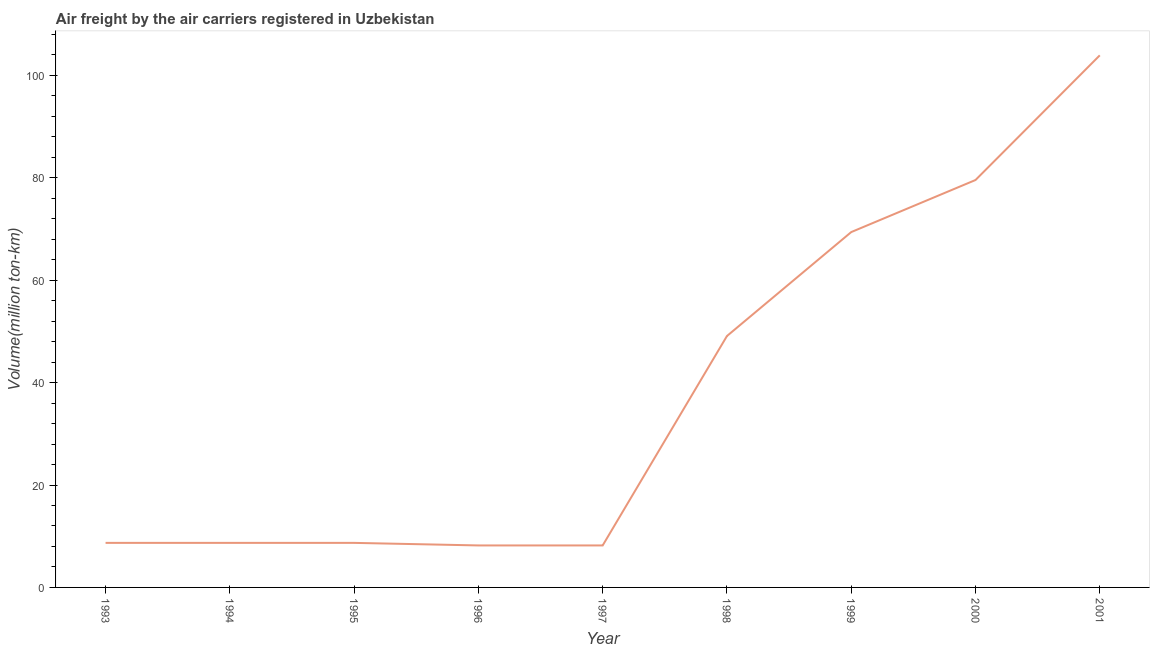What is the air freight in 1994?
Ensure brevity in your answer.  8.7. Across all years, what is the maximum air freight?
Your answer should be very brief. 103.92. Across all years, what is the minimum air freight?
Give a very brief answer. 8.2. In which year was the air freight maximum?
Your answer should be compact. 2001. What is the sum of the air freight?
Ensure brevity in your answer.  344.49. What is the average air freight per year?
Give a very brief answer. 38.28. What is the median air freight?
Give a very brief answer. 8.7. What is the ratio of the air freight in 1995 to that in 2000?
Your response must be concise. 0.11. Is the difference between the air freight in 1995 and 1998 greater than the difference between any two years?
Your answer should be compact. No. What is the difference between the highest and the second highest air freight?
Your answer should be compact. 24.35. Is the sum of the air freight in 1999 and 2000 greater than the maximum air freight across all years?
Give a very brief answer. Yes. What is the difference between the highest and the lowest air freight?
Provide a succinct answer. 95.72. In how many years, is the air freight greater than the average air freight taken over all years?
Your response must be concise. 4. Does the air freight monotonically increase over the years?
Offer a very short reply. No. How many lines are there?
Give a very brief answer. 1. How many years are there in the graph?
Offer a terse response. 9. Are the values on the major ticks of Y-axis written in scientific E-notation?
Provide a short and direct response. No. Does the graph contain grids?
Ensure brevity in your answer.  No. What is the title of the graph?
Your answer should be very brief. Air freight by the air carriers registered in Uzbekistan. What is the label or title of the X-axis?
Make the answer very short. Year. What is the label or title of the Y-axis?
Provide a short and direct response. Volume(million ton-km). What is the Volume(million ton-km) of 1993?
Offer a very short reply. 8.7. What is the Volume(million ton-km) in 1994?
Your response must be concise. 8.7. What is the Volume(million ton-km) in 1995?
Your response must be concise. 8.7. What is the Volume(million ton-km) in 1996?
Provide a succinct answer. 8.2. What is the Volume(million ton-km) of 1997?
Your answer should be compact. 8.2. What is the Volume(million ton-km) in 1998?
Give a very brief answer. 49.1. What is the Volume(million ton-km) in 1999?
Your response must be concise. 69.4. What is the Volume(million ton-km) of 2000?
Make the answer very short. 79.57. What is the Volume(million ton-km) of 2001?
Your response must be concise. 103.92. What is the difference between the Volume(million ton-km) in 1993 and 1994?
Give a very brief answer. 0. What is the difference between the Volume(million ton-km) in 1993 and 1995?
Offer a very short reply. 0. What is the difference between the Volume(million ton-km) in 1993 and 1998?
Keep it short and to the point. -40.4. What is the difference between the Volume(million ton-km) in 1993 and 1999?
Your answer should be very brief. -60.7. What is the difference between the Volume(million ton-km) in 1993 and 2000?
Ensure brevity in your answer.  -70.87. What is the difference between the Volume(million ton-km) in 1993 and 2001?
Make the answer very short. -95.22. What is the difference between the Volume(million ton-km) in 1994 and 1996?
Offer a terse response. 0.5. What is the difference between the Volume(million ton-km) in 1994 and 1997?
Keep it short and to the point. 0.5. What is the difference between the Volume(million ton-km) in 1994 and 1998?
Make the answer very short. -40.4. What is the difference between the Volume(million ton-km) in 1994 and 1999?
Offer a very short reply. -60.7. What is the difference between the Volume(million ton-km) in 1994 and 2000?
Your answer should be very brief. -70.87. What is the difference between the Volume(million ton-km) in 1994 and 2001?
Offer a terse response. -95.22. What is the difference between the Volume(million ton-km) in 1995 and 1998?
Provide a succinct answer. -40.4. What is the difference between the Volume(million ton-km) in 1995 and 1999?
Make the answer very short. -60.7. What is the difference between the Volume(million ton-km) in 1995 and 2000?
Ensure brevity in your answer.  -70.87. What is the difference between the Volume(million ton-km) in 1995 and 2001?
Your response must be concise. -95.22. What is the difference between the Volume(million ton-km) in 1996 and 1997?
Offer a very short reply. 0. What is the difference between the Volume(million ton-km) in 1996 and 1998?
Give a very brief answer. -40.9. What is the difference between the Volume(million ton-km) in 1996 and 1999?
Ensure brevity in your answer.  -61.2. What is the difference between the Volume(million ton-km) in 1996 and 2000?
Provide a succinct answer. -71.37. What is the difference between the Volume(million ton-km) in 1996 and 2001?
Your answer should be compact. -95.72. What is the difference between the Volume(million ton-km) in 1997 and 1998?
Your response must be concise. -40.9. What is the difference between the Volume(million ton-km) in 1997 and 1999?
Provide a short and direct response. -61.2. What is the difference between the Volume(million ton-km) in 1997 and 2000?
Your answer should be compact. -71.37. What is the difference between the Volume(million ton-km) in 1997 and 2001?
Offer a very short reply. -95.72. What is the difference between the Volume(million ton-km) in 1998 and 1999?
Offer a very short reply. -20.3. What is the difference between the Volume(million ton-km) in 1998 and 2000?
Your answer should be compact. -30.47. What is the difference between the Volume(million ton-km) in 1998 and 2001?
Your answer should be very brief. -54.82. What is the difference between the Volume(million ton-km) in 1999 and 2000?
Provide a succinct answer. -10.17. What is the difference between the Volume(million ton-km) in 1999 and 2001?
Offer a terse response. -34.52. What is the difference between the Volume(million ton-km) in 2000 and 2001?
Your response must be concise. -24.35. What is the ratio of the Volume(million ton-km) in 1993 to that in 1996?
Provide a succinct answer. 1.06. What is the ratio of the Volume(million ton-km) in 1993 to that in 1997?
Give a very brief answer. 1.06. What is the ratio of the Volume(million ton-km) in 1993 to that in 1998?
Your answer should be very brief. 0.18. What is the ratio of the Volume(million ton-km) in 1993 to that in 1999?
Give a very brief answer. 0.12. What is the ratio of the Volume(million ton-km) in 1993 to that in 2000?
Provide a short and direct response. 0.11. What is the ratio of the Volume(million ton-km) in 1993 to that in 2001?
Give a very brief answer. 0.08. What is the ratio of the Volume(million ton-km) in 1994 to that in 1996?
Offer a very short reply. 1.06. What is the ratio of the Volume(million ton-km) in 1994 to that in 1997?
Give a very brief answer. 1.06. What is the ratio of the Volume(million ton-km) in 1994 to that in 1998?
Offer a terse response. 0.18. What is the ratio of the Volume(million ton-km) in 1994 to that in 2000?
Your response must be concise. 0.11. What is the ratio of the Volume(million ton-km) in 1994 to that in 2001?
Your response must be concise. 0.08. What is the ratio of the Volume(million ton-km) in 1995 to that in 1996?
Make the answer very short. 1.06. What is the ratio of the Volume(million ton-km) in 1995 to that in 1997?
Your answer should be very brief. 1.06. What is the ratio of the Volume(million ton-km) in 1995 to that in 1998?
Your answer should be very brief. 0.18. What is the ratio of the Volume(million ton-km) in 1995 to that in 2000?
Keep it short and to the point. 0.11. What is the ratio of the Volume(million ton-km) in 1995 to that in 2001?
Offer a terse response. 0.08. What is the ratio of the Volume(million ton-km) in 1996 to that in 1997?
Ensure brevity in your answer.  1. What is the ratio of the Volume(million ton-km) in 1996 to that in 1998?
Offer a terse response. 0.17. What is the ratio of the Volume(million ton-km) in 1996 to that in 1999?
Ensure brevity in your answer.  0.12. What is the ratio of the Volume(million ton-km) in 1996 to that in 2000?
Ensure brevity in your answer.  0.1. What is the ratio of the Volume(million ton-km) in 1996 to that in 2001?
Your answer should be very brief. 0.08. What is the ratio of the Volume(million ton-km) in 1997 to that in 1998?
Offer a terse response. 0.17. What is the ratio of the Volume(million ton-km) in 1997 to that in 1999?
Provide a short and direct response. 0.12. What is the ratio of the Volume(million ton-km) in 1997 to that in 2000?
Keep it short and to the point. 0.1. What is the ratio of the Volume(million ton-km) in 1997 to that in 2001?
Give a very brief answer. 0.08. What is the ratio of the Volume(million ton-km) in 1998 to that in 1999?
Make the answer very short. 0.71. What is the ratio of the Volume(million ton-km) in 1998 to that in 2000?
Provide a short and direct response. 0.62. What is the ratio of the Volume(million ton-km) in 1998 to that in 2001?
Ensure brevity in your answer.  0.47. What is the ratio of the Volume(million ton-km) in 1999 to that in 2000?
Provide a succinct answer. 0.87. What is the ratio of the Volume(million ton-km) in 1999 to that in 2001?
Your answer should be compact. 0.67. What is the ratio of the Volume(million ton-km) in 2000 to that in 2001?
Your answer should be compact. 0.77. 